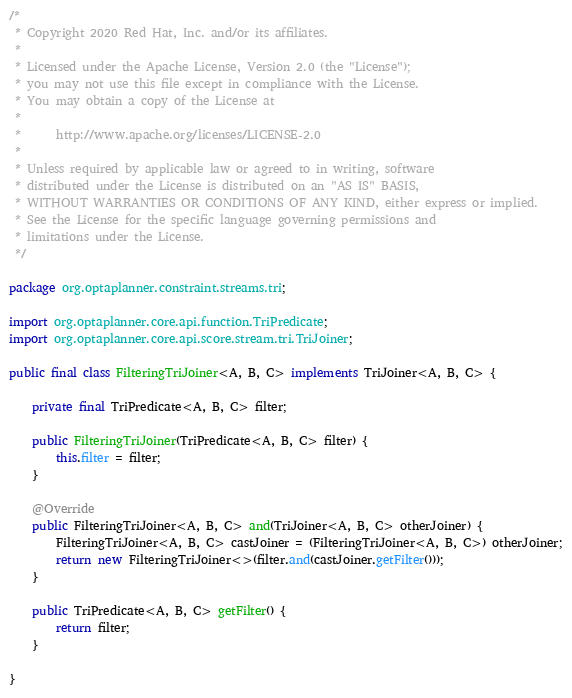Convert code to text. <code><loc_0><loc_0><loc_500><loc_500><_Java_>/*
 * Copyright 2020 Red Hat, Inc. and/or its affiliates.
 *
 * Licensed under the Apache License, Version 2.0 (the "License");
 * you may not use this file except in compliance with the License.
 * You may obtain a copy of the License at
 *
 *      http://www.apache.org/licenses/LICENSE-2.0
 *
 * Unless required by applicable law or agreed to in writing, software
 * distributed under the License is distributed on an "AS IS" BASIS,
 * WITHOUT WARRANTIES OR CONDITIONS OF ANY KIND, either express or implied.
 * See the License for the specific language governing permissions and
 * limitations under the License.
 */

package org.optaplanner.constraint.streams.tri;

import org.optaplanner.core.api.function.TriPredicate;
import org.optaplanner.core.api.score.stream.tri.TriJoiner;

public final class FilteringTriJoiner<A, B, C> implements TriJoiner<A, B, C> {

    private final TriPredicate<A, B, C> filter;

    public FilteringTriJoiner(TriPredicate<A, B, C> filter) {
        this.filter = filter;
    }

    @Override
    public FilteringTriJoiner<A, B, C> and(TriJoiner<A, B, C> otherJoiner) {
        FilteringTriJoiner<A, B, C> castJoiner = (FilteringTriJoiner<A, B, C>) otherJoiner;
        return new FilteringTriJoiner<>(filter.and(castJoiner.getFilter()));
    }

    public TriPredicate<A, B, C> getFilter() {
        return filter;
    }

}
</code> 